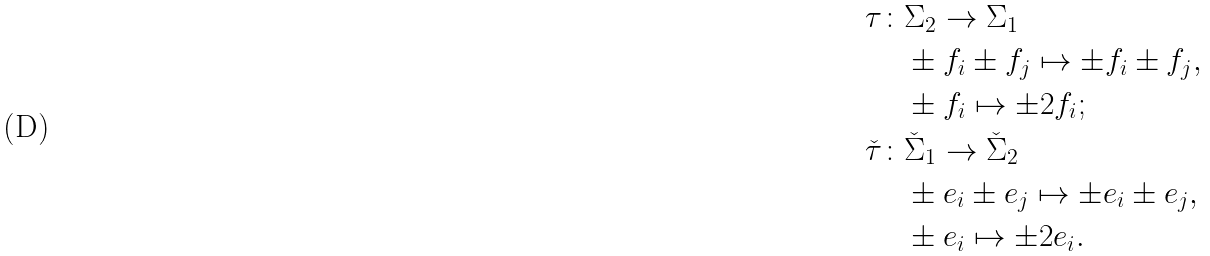<formula> <loc_0><loc_0><loc_500><loc_500>\tau \colon & \Sigma _ { 2 } \to \Sigma _ { 1 } \\ & \pm f _ { i } \pm f _ { j } \mapsto \pm f _ { i } \pm f _ { j } , \\ & \pm f _ { i } \mapsto \pm 2 f _ { i } ; \\ \check { \tau } \colon & \check { \Sigma } _ { 1 } \to \check { \Sigma } _ { 2 } \\ & \pm e _ { i } \pm e _ { j } \mapsto \pm e _ { i } \pm e _ { j } , \\ & \pm e _ { i } \mapsto \pm 2 e _ { i } .</formula> 